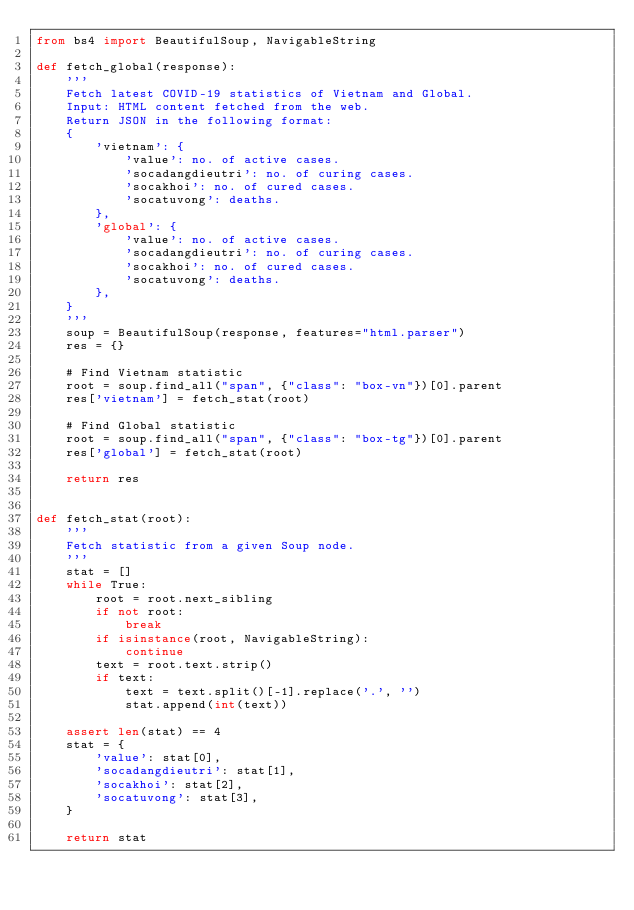Convert code to text. <code><loc_0><loc_0><loc_500><loc_500><_Python_>from bs4 import BeautifulSoup, NavigableString

def fetch_global(response):
    '''
    Fetch latest COVID-19 statistics of Vietnam and Global.
    Input: HTML content fetched from the web.
    Return JSON in the following format:
    {
        'vietnam': {
            'value': no. of active cases.
            'socadangdieutri': no. of curing cases.
            'socakhoi': no. of cured cases.
            'socatuvong': deaths.
        },
        'global': {
            'value': no. of active cases.
            'socadangdieutri': no. of curing cases.
            'socakhoi': no. of cured cases.
            'socatuvong': deaths.
        },
    }
    '''
    soup = BeautifulSoup(response, features="html.parser")
    res = {}
    
    # Find Vietnam statistic
    root = soup.find_all("span", {"class": "box-vn"})[0].parent
    res['vietnam'] = fetch_stat(root)
    
    # Find Global statistic
    root = soup.find_all("span", {"class": "box-tg"})[0].parent
    res['global'] = fetch_stat(root)
    
    return res
    

def fetch_stat(root):
    '''
    Fetch statistic from a given Soup node.
    '''
    stat = []
    while True:
        root = root.next_sibling
        if not root:
            break
        if isinstance(root, NavigableString):
            continue
        text = root.text.strip()
        if text:
            text = text.split()[-1].replace('.', '')
            stat.append(int(text))
            
    assert len(stat) == 4
    stat = {
        'value': stat[0],
        'socadangdieutri': stat[1],
        'socakhoi': stat[2],
        'socatuvong': stat[3],
    }
    
    return stat</code> 